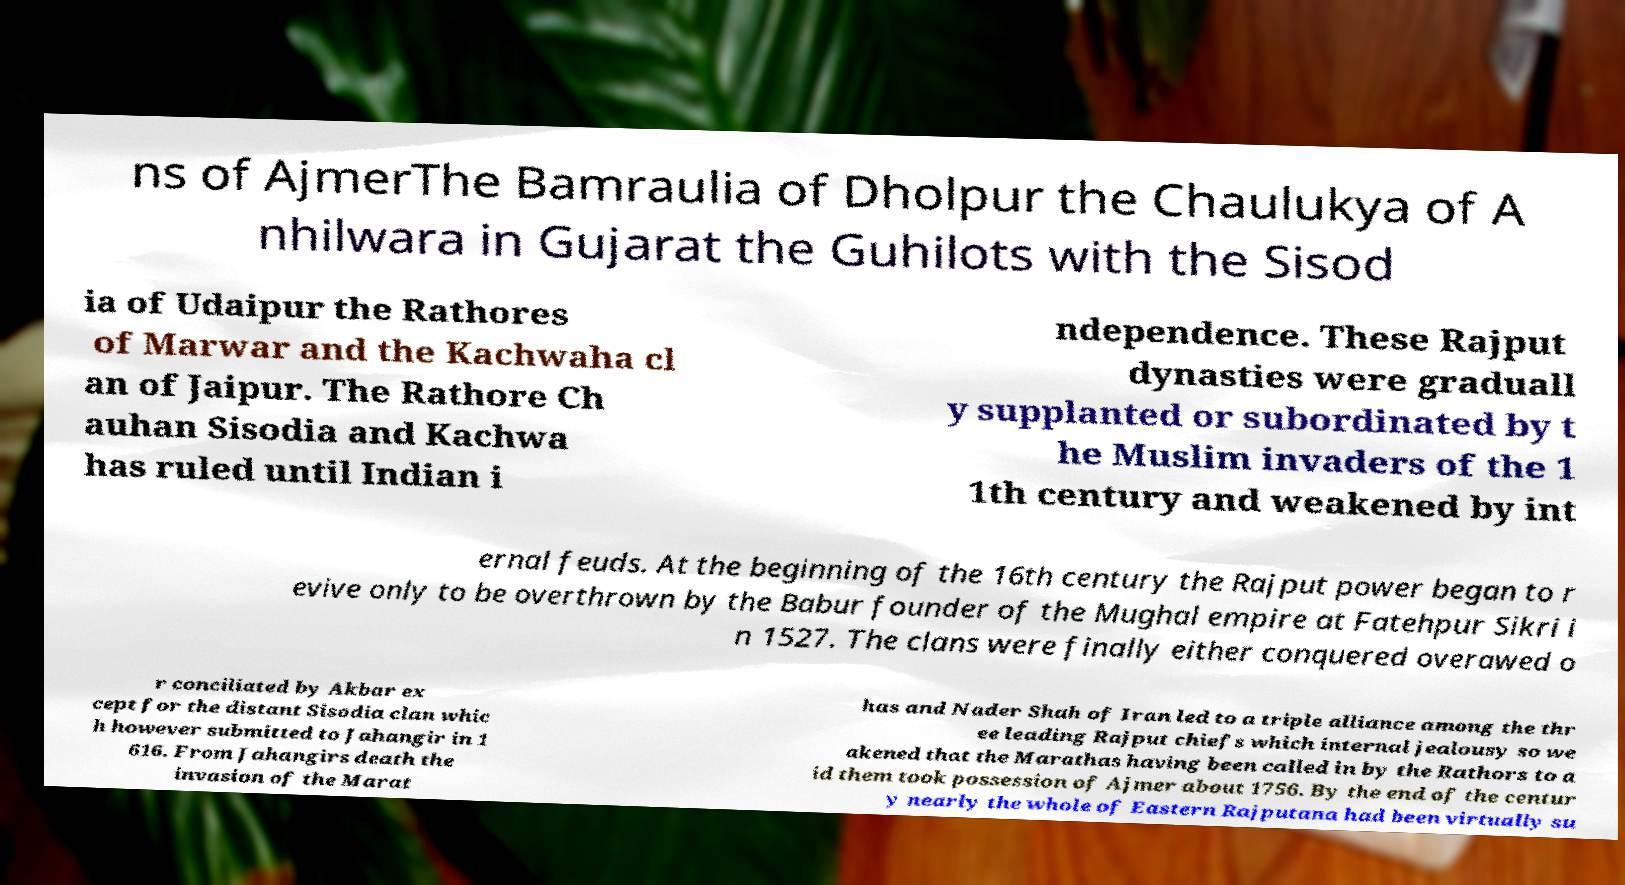Can you accurately transcribe the text from the provided image for me? ns of AjmerThe Bamraulia of Dholpur the Chaulukya of A nhilwara in Gujarat the Guhilots with the Sisod ia of Udaipur the Rathores of Marwar and the Kachwaha cl an of Jaipur. The Rathore Ch auhan Sisodia and Kachwa has ruled until Indian i ndependence. These Rajput dynasties were graduall y supplanted or subordinated by t he Muslim invaders of the 1 1th century and weakened by int ernal feuds. At the beginning of the 16th century the Rajput power began to r evive only to be overthrown by the Babur founder of the Mughal empire at Fatehpur Sikri i n 1527. The clans were finally either conquered overawed o r conciliated by Akbar ex cept for the distant Sisodia clan whic h however submitted to Jahangir in 1 616. From Jahangirs death the invasion of the Marat has and Nader Shah of Iran led to a triple alliance among the thr ee leading Rajput chiefs which internal jealousy so we akened that the Marathas having been called in by the Rathors to a id them took possession of Ajmer about 1756. By the end of the centur y nearly the whole of Eastern Rajputana had been virtually su 